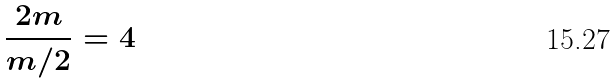<formula> <loc_0><loc_0><loc_500><loc_500>\frac { 2 m } { m / 2 } = 4</formula> 